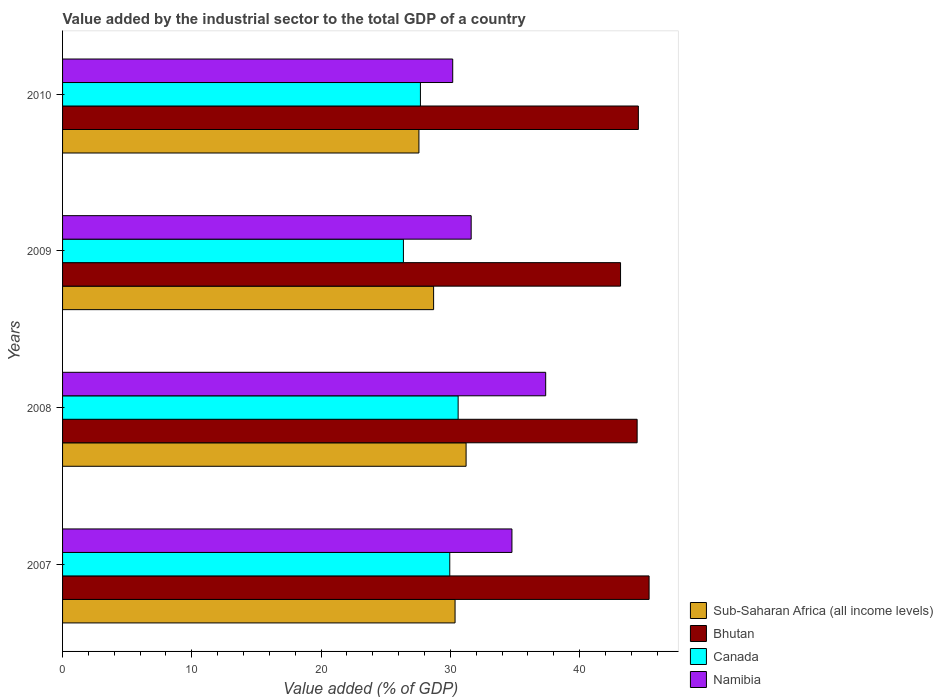How many different coloured bars are there?
Make the answer very short. 4. How many groups of bars are there?
Your answer should be compact. 4. What is the label of the 4th group of bars from the top?
Ensure brevity in your answer.  2007. What is the value added by the industrial sector to the total GDP in Sub-Saharan Africa (all income levels) in 2009?
Offer a very short reply. 28.71. Across all years, what is the maximum value added by the industrial sector to the total GDP in Sub-Saharan Africa (all income levels)?
Your answer should be very brief. 31.22. Across all years, what is the minimum value added by the industrial sector to the total GDP in Namibia?
Provide a short and direct response. 30.18. In which year was the value added by the industrial sector to the total GDP in Sub-Saharan Africa (all income levels) maximum?
Your answer should be compact. 2008. What is the total value added by the industrial sector to the total GDP in Canada in the graph?
Give a very brief answer. 114.61. What is the difference between the value added by the industrial sector to the total GDP in Namibia in 2008 and that in 2010?
Give a very brief answer. 7.19. What is the difference between the value added by the industrial sector to the total GDP in Sub-Saharan Africa (all income levels) in 2009 and the value added by the industrial sector to the total GDP in Canada in 2007?
Your answer should be compact. -1.25. What is the average value added by the industrial sector to the total GDP in Sub-Saharan Africa (all income levels) per year?
Offer a terse response. 29.46. In the year 2007, what is the difference between the value added by the industrial sector to the total GDP in Namibia and value added by the industrial sector to the total GDP in Sub-Saharan Africa (all income levels)?
Your answer should be compact. 4.4. What is the ratio of the value added by the industrial sector to the total GDP in Bhutan in 2009 to that in 2010?
Your response must be concise. 0.97. What is the difference between the highest and the second highest value added by the industrial sector to the total GDP in Bhutan?
Provide a short and direct response. 0.83. What is the difference between the highest and the lowest value added by the industrial sector to the total GDP in Canada?
Your answer should be compact. 4.23. In how many years, is the value added by the industrial sector to the total GDP in Canada greater than the average value added by the industrial sector to the total GDP in Canada taken over all years?
Provide a short and direct response. 2. Is the sum of the value added by the industrial sector to the total GDP in Namibia in 2007 and 2009 greater than the maximum value added by the industrial sector to the total GDP in Canada across all years?
Your answer should be compact. Yes. Is it the case that in every year, the sum of the value added by the industrial sector to the total GDP in Namibia and value added by the industrial sector to the total GDP in Bhutan is greater than the sum of value added by the industrial sector to the total GDP in Sub-Saharan Africa (all income levels) and value added by the industrial sector to the total GDP in Canada?
Ensure brevity in your answer.  Yes. What does the 2nd bar from the top in 2010 represents?
Ensure brevity in your answer.  Canada. What does the 4th bar from the bottom in 2010 represents?
Your response must be concise. Namibia. How many bars are there?
Give a very brief answer. 16. Are all the bars in the graph horizontal?
Provide a succinct answer. Yes. How many years are there in the graph?
Your answer should be compact. 4. What is the difference between two consecutive major ticks on the X-axis?
Make the answer very short. 10. Does the graph contain any zero values?
Offer a very short reply. No. How many legend labels are there?
Keep it short and to the point. 4. What is the title of the graph?
Your response must be concise. Value added by the industrial sector to the total GDP of a country. Does "Kosovo" appear as one of the legend labels in the graph?
Offer a terse response. No. What is the label or title of the X-axis?
Offer a terse response. Value added (% of GDP). What is the label or title of the Y-axis?
Make the answer very short. Years. What is the Value added (% of GDP) of Sub-Saharan Africa (all income levels) in 2007?
Make the answer very short. 30.37. What is the Value added (% of GDP) in Bhutan in 2007?
Your answer should be very brief. 45.38. What is the Value added (% of GDP) in Canada in 2007?
Your response must be concise. 29.95. What is the Value added (% of GDP) of Namibia in 2007?
Give a very brief answer. 34.77. What is the Value added (% of GDP) of Sub-Saharan Africa (all income levels) in 2008?
Make the answer very short. 31.22. What is the Value added (% of GDP) in Bhutan in 2008?
Your answer should be compact. 44.45. What is the Value added (% of GDP) in Canada in 2008?
Keep it short and to the point. 30.6. What is the Value added (% of GDP) of Namibia in 2008?
Your response must be concise. 37.38. What is the Value added (% of GDP) in Sub-Saharan Africa (all income levels) in 2009?
Your answer should be compact. 28.71. What is the Value added (% of GDP) of Bhutan in 2009?
Ensure brevity in your answer.  43.17. What is the Value added (% of GDP) of Canada in 2009?
Your answer should be very brief. 26.37. What is the Value added (% of GDP) in Namibia in 2009?
Give a very brief answer. 31.61. What is the Value added (% of GDP) in Sub-Saharan Africa (all income levels) in 2010?
Offer a very short reply. 27.57. What is the Value added (% of GDP) in Bhutan in 2010?
Keep it short and to the point. 44.55. What is the Value added (% of GDP) in Canada in 2010?
Ensure brevity in your answer.  27.69. What is the Value added (% of GDP) in Namibia in 2010?
Make the answer very short. 30.18. Across all years, what is the maximum Value added (% of GDP) of Sub-Saharan Africa (all income levels)?
Offer a very short reply. 31.22. Across all years, what is the maximum Value added (% of GDP) in Bhutan?
Your answer should be compact. 45.38. Across all years, what is the maximum Value added (% of GDP) in Canada?
Your answer should be compact. 30.6. Across all years, what is the maximum Value added (% of GDP) in Namibia?
Give a very brief answer. 37.38. Across all years, what is the minimum Value added (% of GDP) of Sub-Saharan Africa (all income levels)?
Offer a very short reply. 27.57. Across all years, what is the minimum Value added (% of GDP) in Bhutan?
Provide a short and direct response. 43.17. Across all years, what is the minimum Value added (% of GDP) of Canada?
Provide a short and direct response. 26.37. Across all years, what is the minimum Value added (% of GDP) of Namibia?
Ensure brevity in your answer.  30.18. What is the total Value added (% of GDP) of Sub-Saharan Africa (all income levels) in the graph?
Provide a succinct answer. 117.86. What is the total Value added (% of GDP) in Bhutan in the graph?
Offer a terse response. 177.54. What is the total Value added (% of GDP) of Canada in the graph?
Offer a terse response. 114.61. What is the total Value added (% of GDP) in Namibia in the graph?
Give a very brief answer. 133.94. What is the difference between the Value added (% of GDP) of Sub-Saharan Africa (all income levels) in 2007 and that in 2008?
Offer a very short reply. -0.85. What is the difference between the Value added (% of GDP) of Bhutan in 2007 and that in 2008?
Offer a terse response. 0.92. What is the difference between the Value added (% of GDP) in Canada in 2007 and that in 2008?
Make the answer very short. -0.65. What is the difference between the Value added (% of GDP) in Namibia in 2007 and that in 2008?
Provide a short and direct response. -2.61. What is the difference between the Value added (% of GDP) of Sub-Saharan Africa (all income levels) in 2007 and that in 2009?
Offer a very short reply. 1.66. What is the difference between the Value added (% of GDP) in Bhutan in 2007 and that in 2009?
Offer a terse response. 2.21. What is the difference between the Value added (% of GDP) of Canada in 2007 and that in 2009?
Your answer should be very brief. 3.59. What is the difference between the Value added (% of GDP) in Namibia in 2007 and that in 2009?
Offer a very short reply. 3.15. What is the difference between the Value added (% of GDP) in Sub-Saharan Africa (all income levels) in 2007 and that in 2010?
Make the answer very short. 2.8. What is the difference between the Value added (% of GDP) of Bhutan in 2007 and that in 2010?
Make the answer very short. 0.83. What is the difference between the Value added (% of GDP) of Canada in 2007 and that in 2010?
Give a very brief answer. 2.27. What is the difference between the Value added (% of GDP) of Namibia in 2007 and that in 2010?
Your answer should be very brief. 4.58. What is the difference between the Value added (% of GDP) of Sub-Saharan Africa (all income levels) in 2008 and that in 2009?
Provide a succinct answer. 2.51. What is the difference between the Value added (% of GDP) in Bhutan in 2008 and that in 2009?
Your answer should be very brief. 1.28. What is the difference between the Value added (% of GDP) in Canada in 2008 and that in 2009?
Offer a terse response. 4.23. What is the difference between the Value added (% of GDP) of Namibia in 2008 and that in 2009?
Provide a short and direct response. 5.77. What is the difference between the Value added (% of GDP) of Sub-Saharan Africa (all income levels) in 2008 and that in 2010?
Your response must be concise. 3.65. What is the difference between the Value added (% of GDP) in Bhutan in 2008 and that in 2010?
Your answer should be compact. -0.09. What is the difference between the Value added (% of GDP) in Canada in 2008 and that in 2010?
Make the answer very short. 2.92. What is the difference between the Value added (% of GDP) of Namibia in 2008 and that in 2010?
Offer a terse response. 7.19. What is the difference between the Value added (% of GDP) of Sub-Saharan Africa (all income levels) in 2009 and that in 2010?
Your answer should be very brief. 1.14. What is the difference between the Value added (% of GDP) in Bhutan in 2009 and that in 2010?
Make the answer very short. -1.38. What is the difference between the Value added (% of GDP) in Canada in 2009 and that in 2010?
Your response must be concise. -1.32. What is the difference between the Value added (% of GDP) of Namibia in 2009 and that in 2010?
Offer a terse response. 1.43. What is the difference between the Value added (% of GDP) of Sub-Saharan Africa (all income levels) in 2007 and the Value added (% of GDP) of Bhutan in 2008?
Give a very brief answer. -14.09. What is the difference between the Value added (% of GDP) of Sub-Saharan Africa (all income levels) in 2007 and the Value added (% of GDP) of Canada in 2008?
Offer a very short reply. -0.24. What is the difference between the Value added (% of GDP) of Sub-Saharan Africa (all income levels) in 2007 and the Value added (% of GDP) of Namibia in 2008?
Make the answer very short. -7.01. What is the difference between the Value added (% of GDP) in Bhutan in 2007 and the Value added (% of GDP) in Canada in 2008?
Your answer should be compact. 14.77. What is the difference between the Value added (% of GDP) in Bhutan in 2007 and the Value added (% of GDP) in Namibia in 2008?
Your response must be concise. 8. What is the difference between the Value added (% of GDP) in Canada in 2007 and the Value added (% of GDP) in Namibia in 2008?
Offer a very short reply. -7.42. What is the difference between the Value added (% of GDP) in Sub-Saharan Africa (all income levels) in 2007 and the Value added (% of GDP) in Bhutan in 2009?
Your answer should be very brief. -12.8. What is the difference between the Value added (% of GDP) of Sub-Saharan Africa (all income levels) in 2007 and the Value added (% of GDP) of Canada in 2009?
Your answer should be very brief. 4. What is the difference between the Value added (% of GDP) in Sub-Saharan Africa (all income levels) in 2007 and the Value added (% of GDP) in Namibia in 2009?
Your answer should be very brief. -1.25. What is the difference between the Value added (% of GDP) of Bhutan in 2007 and the Value added (% of GDP) of Canada in 2009?
Provide a succinct answer. 19.01. What is the difference between the Value added (% of GDP) in Bhutan in 2007 and the Value added (% of GDP) in Namibia in 2009?
Offer a terse response. 13.76. What is the difference between the Value added (% of GDP) of Canada in 2007 and the Value added (% of GDP) of Namibia in 2009?
Provide a succinct answer. -1.66. What is the difference between the Value added (% of GDP) of Sub-Saharan Africa (all income levels) in 2007 and the Value added (% of GDP) of Bhutan in 2010?
Give a very brief answer. -14.18. What is the difference between the Value added (% of GDP) in Sub-Saharan Africa (all income levels) in 2007 and the Value added (% of GDP) in Canada in 2010?
Make the answer very short. 2.68. What is the difference between the Value added (% of GDP) in Sub-Saharan Africa (all income levels) in 2007 and the Value added (% of GDP) in Namibia in 2010?
Offer a terse response. 0.18. What is the difference between the Value added (% of GDP) of Bhutan in 2007 and the Value added (% of GDP) of Canada in 2010?
Offer a very short reply. 17.69. What is the difference between the Value added (% of GDP) in Bhutan in 2007 and the Value added (% of GDP) in Namibia in 2010?
Your response must be concise. 15.19. What is the difference between the Value added (% of GDP) in Canada in 2007 and the Value added (% of GDP) in Namibia in 2010?
Your answer should be very brief. -0.23. What is the difference between the Value added (% of GDP) of Sub-Saharan Africa (all income levels) in 2008 and the Value added (% of GDP) of Bhutan in 2009?
Give a very brief answer. -11.95. What is the difference between the Value added (% of GDP) in Sub-Saharan Africa (all income levels) in 2008 and the Value added (% of GDP) in Canada in 2009?
Keep it short and to the point. 4.85. What is the difference between the Value added (% of GDP) in Sub-Saharan Africa (all income levels) in 2008 and the Value added (% of GDP) in Namibia in 2009?
Ensure brevity in your answer.  -0.39. What is the difference between the Value added (% of GDP) of Bhutan in 2008 and the Value added (% of GDP) of Canada in 2009?
Your answer should be compact. 18.08. What is the difference between the Value added (% of GDP) in Bhutan in 2008 and the Value added (% of GDP) in Namibia in 2009?
Make the answer very short. 12.84. What is the difference between the Value added (% of GDP) in Canada in 2008 and the Value added (% of GDP) in Namibia in 2009?
Offer a terse response. -1.01. What is the difference between the Value added (% of GDP) in Sub-Saharan Africa (all income levels) in 2008 and the Value added (% of GDP) in Bhutan in 2010?
Your answer should be compact. -13.33. What is the difference between the Value added (% of GDP) in Sub-Saharan Africa (all income levels) in 2008 and the Value added (% of GDP) in Canada in 2010?
Offer a very short reply. 3.53. What is the difference between the Value added (% of GDP) of Sub-Saharan Africa (all income levels) in 2008 and the Value added (% of GDP) of Namibia in 2010?
Keep it short and to the point. 1.03. What is the difference between the Value added (% of GDP) in Bhutan in 2008 and the Value added (% of GDP) in Canada in 2010?
Make the answer very short. 16.77. What is the difference between the Value added (% of GDP) in Bhutan in 2008 and the Value added (% of GDP) in Namibia in 2010?
Provide a succinct answer. 14.27. What is the difference between the Value added (% of GDP) in Canada in 2008 and the Value added (% of GDP) in Namibia in 2010?
Give a very brief answer. 0.42. What is the difference between the Value added (% of GDP) of Sub-Saharan Africa (all income levels) in 2009 and the Value added (% of GDP) of Bhutan in 2010?
Provide a succinct answer. -15.84. What is the difference between the Value added (% of GDP) in Sub-Saharan Africa (all income levels) in 2009 and the Value added (% of GDP) in Canada in 2010?
Make the answer very short. 1.02. What is the difference between the Value added (% of GDP) in Sub-Saharan Africa (all income levels) in 2009 and the Value added (% of GDP) in Namibia in 2010?
Give a very brief answer. -1.48. What is the difference between the Value added (% of GDP) of Bhutan in 2009 and the Value added (% of GDP) of Canada in 2010?
Offer a terse response. 15.48. What is the difference between the Value added (% of GDP) in Bhutan in 2009 and the Value added (% of GDP) in Namibia in 2010?
Your answer should be compact. 12.98. What is the difference between the Value added (% of GDP) of Canada in 2009 and the Value added (% of GDP) of Namibia in 2010?
Offer a terse response. -3.81. What is the average Value added (% of GDP) in Sub-Saharan Africa (all income levels) per year?
Make the answer very short. 29.46. What is the average Value added (% of GDP) in Bhutan per year?
Provide a succinct answer. 44.39. What is the average Value added (% of GDP) of Canada per year?
Your answer should be very brief. 28.65. What is the average Value added (% of GDP) of Namibia per year?
Give a very brief answer. 33.48. In the year 2007, what is the difference between the Value added (% of GDP) in Sub-Saharan Africa (all income levels) and Value added (% of GDP) in Bhutan?
Provide a succinct answer. -15.01. In the year 2007, what is the difference between the Value added (% of GDP) in Sub-Saharan Africa (all income levels) and Value added (% of GDP) in Canada?
Your answer should be compact. 0.41. In the year 2007, what is the difference between the Value added (% of GDP) of Sub-Saharan Africa (all income levels) and Value added (% of GDP) of Namibia?
Your answer should be very brief. -4.4. In the year 2007, what is the difference between the Value added (% of GDP) of Bhutan and Value added (% of GDP) of Canada?
Your response must be concise. 15.42. In the year 2007, what is the difference between the Value added (% of GDP) of Bhutan and Value added (% of GDP) of Namibia?
Make the answer very short. 10.61. In the year 2007, what is the difference between the Value added (% of GDP) of Canada and Value added (% of GDP) of Namibia?
Ensure brevity in your answer.  -4.81. In the year 2008, what is the difference between the Value added (% of GDP) of Sub-Saharan Africa (all income levels) and Value added (% of GDP) of Bhutan?
Your answer should be compact. -13.23. In the year 2008, what is the difference between the Value added (% of GDP) in Sub-Saharan Africa (all income levels) and Value added (% of GDP) in Canada?
Your answer should be very brief. 0.62. In the year 2008, what is the difference between the Value added (% of GDP) of Sub-Saharan Africa (all income levels) and Value added (% of GDP) of Namibia?
Provide a short and direct response. -6.16. In the year 2008, what is the difference between the Value added (% of GDP) of Bhutan and Value added (% of GDP) of Canada?
Your answer should be compact. 13.85. In the year 2008, what is the difference between the Value added (% of GDP) of Bhutan and Value added (% of GDP) of Namibia?
Offer a terse response. 7.08. In the year 2008, what is the difference between the Value added (% of GDP) in Canada and Value added (% of GDP) in Namibia?
Provide a short and direct response. -6.77. In the year 2009, what is the difference between the Value added (% of GDP) of Sub-Saharan Africa (all income levels) and Value added (% of GDP) of Bhutan?
Provide a succinct answer. -14.46. In the year 2009, what is the difference between the Value added (% of GDP) of Sub-Saharan Africa (all income levels) and Value added (% of GDP) of Canada?
Offer a terse response. 2.34. In the year 2009, what is the difference between the Value added (% of GDP) in Sub-Saharan Africa (all income levels) and Value added (% of GDP) in Namibia?
Your answer should be compact. -2.9. In the year 2009, what is the difference between the Value added (% of GDP) in Bhutan and Value added (% of GDP) in Canada?
Your answer should be compact. 16.8. In the year 2009, what is the difference between the Value added (% of GDP) of Bhutan and Value added (% of GDP) of Namibia?
Offer a very short reply. 11.56. In the year 2009, what is the difference between the Value added (% of GDP) in Canada and Value added (% of GDP) in Namibia?
Your answer should be compact. -5.24. In the year 2010, what is the difference between the Value added (% of GDP) in Sub-Saharan Africa (all income levels) and Value added (% of GDP) in Bhutan?
Offer a very short reply. -16.98. In the year 2010, what is the difference between the Value added (% of GDP) in Sub-Saharan Africa (all income levels) and Value added (% of GDP) in Canada?
Ensure brevity in your answer.  -0.12. In the year 2010, what is the difference between the Value added (% of GDP) of Sub-Saharan Africa (all income levels) and Value added (% of GDP) of Namibia?
Offer a terse response. -2.61. In the year 2010, what is the difference between the Value added (% of GDP) of Bhutan and Value added (% of GDP) of Canada?
Ensure brevity in your answer.  16.86. In the year 2010, what is the difference between the Value added (% of GDP) of Bhutan and Value added (% of GDP) of Namibia?
Ensure brevity in your answer.  14.36. In the year 2010, what is the difference between the Value added (% of GDP) in Canada and Value added (% of GDP) in Namibia?
Give a very brief answer. -2.5. What is the ratio of the Value added (% of GDP) of Sub-Saharan Africa (all income levels) in 2007 to that in 2008?
Provide a succinct answer. 0.97. What is the ratio of the Value added (% of GDP) in Bhutan in 2007 to that in 2008?
Offer a terse response. 1.02. What is the ratio of the Value added (% of GDP) in Canada in 2007 to that in 2008?
Keep it short and to the point. 0.98. What is the ratio of the Value added (% of GDP) in Namibia in 2007 to that in 2008?
Offer a very short reply. 0.93. What is the ratio of the Value added (% of GDP) in Sub-Saharan Africa (all income levels) in 2007 to that in 2009?
Provide a short and direct response. 1.06. What is the ratio of the Value added (% of GDP) of Bhutan in 2007 to that in 2009?
Make the answer very short. 1.05. What is the ratio of the Value added (% of GDP) of Canada in 2007 to that in 2009?
Provide a succinct answer. 1.14. What is the ratio of the Value added (% of GDP) in Namibia in 2007 to that in 2009?
Provide a succinct answer. 1.1. What is the ratio of the Value added (% of GDP) in Sub-Saharan Africa (all income levels) in 2007 to that in 2010?
Make the answer very short. 1.1. What is the ratio of the Value added (% of GDP) of Bhutan in 2007 to that in 2010?
Your answer should be very brief. 1.02. What is the ratio of the Value added (% of GDP) of Canada in 2007 to that in 2010?
Your answer should be very brief. 1.08. What is the ratio of the Value added (% of GDP) of Namibia in 2007 to that in 2010?
Provide a short and direct response. 1.15. What is the ratio of the Value added (% of GDP) in Sub-Saharan Africa (all income levels) in 2008 to that in 2009?
Offer a terse response. 1.09. What is the ratio of the Value added (% of GDP) of Bhutan in 2008 to that in 2009?
Provide a short and direct response. 1.03. What is the ratio of the Value added (% of GDP) of Canada in 2008 to that in 2009?
Your answer should be compact. 1.16. What is the ratio of the Value added (% of GDP) of Namibia in 2008 to that in 2009?
Your answer should be very brief. 1.18. What is the ratio of the Value added (% of GDP) in Sub-Saharan Africa (all income levels) in 2008 to that in 2010?
Offer a very short reply. 1.13. What is the ratio of the Value added (% of GDP) in Canada in 2008 to that in 2010?
Keep it short and to the point. 1.11. What is the ratio of the Value added (% of GDP) in Namibia in 2008 to that in 2010?
Your response must be concise. 1.24. What is the ratio of the Value added (% of GDP) of Sub-Saharan Africa (all income levels) in 2009 to that in 2010?
Your answer should be very brief. 1.04. What is the ratio of the Value added (% of GDP) in Bhutan in 2009 to that in 2010?
Your answer should be compact. 0.97. What is the ratio of the Value added (% of GDP) of Canada in 2009 to that in 2010?
Provide a short and direct response. 0.95. What is the ratio of the Value added (% of GDP) of Namibia in 2009 to that in 2010?
Give a very brief answer. 1.05. What is the difference between the highest and the second highest Value added (% of GDP) in Sub-Saharan Africa (all income levels)?
Offer a very short reply. 0.85. What is the difference between the highest and the second highest Value added (% of GDP) in Bhutan?
Ensure brevity in your answer.  0.83. What is the difference between the highest and the second highest Value added (% of GDP) of Canada?
Your answer should be compact. 0.65. What is the difference between the highest and the second highest Value added (% of GDP) in Namibia?
Provide a succinct answer. 2.61. What is the difference between the highest and the lowest Value added (% of GDP) of Sub-Saharan Africa (all income levels)?
Your answer should be compact. 3.65. What is the difference between the highest and the lowest Value added (% of GDP) of Bhutan?
Your answer should be compact. 2.21. What is the difference between the highest and the lowest Value added (% of GDP) of Canada?
Offer a terse response. 4.23. What is the difference between the highest and the lowest Value added (% of GDP) of Namibia?
Give a very brief answer. 7.19. 